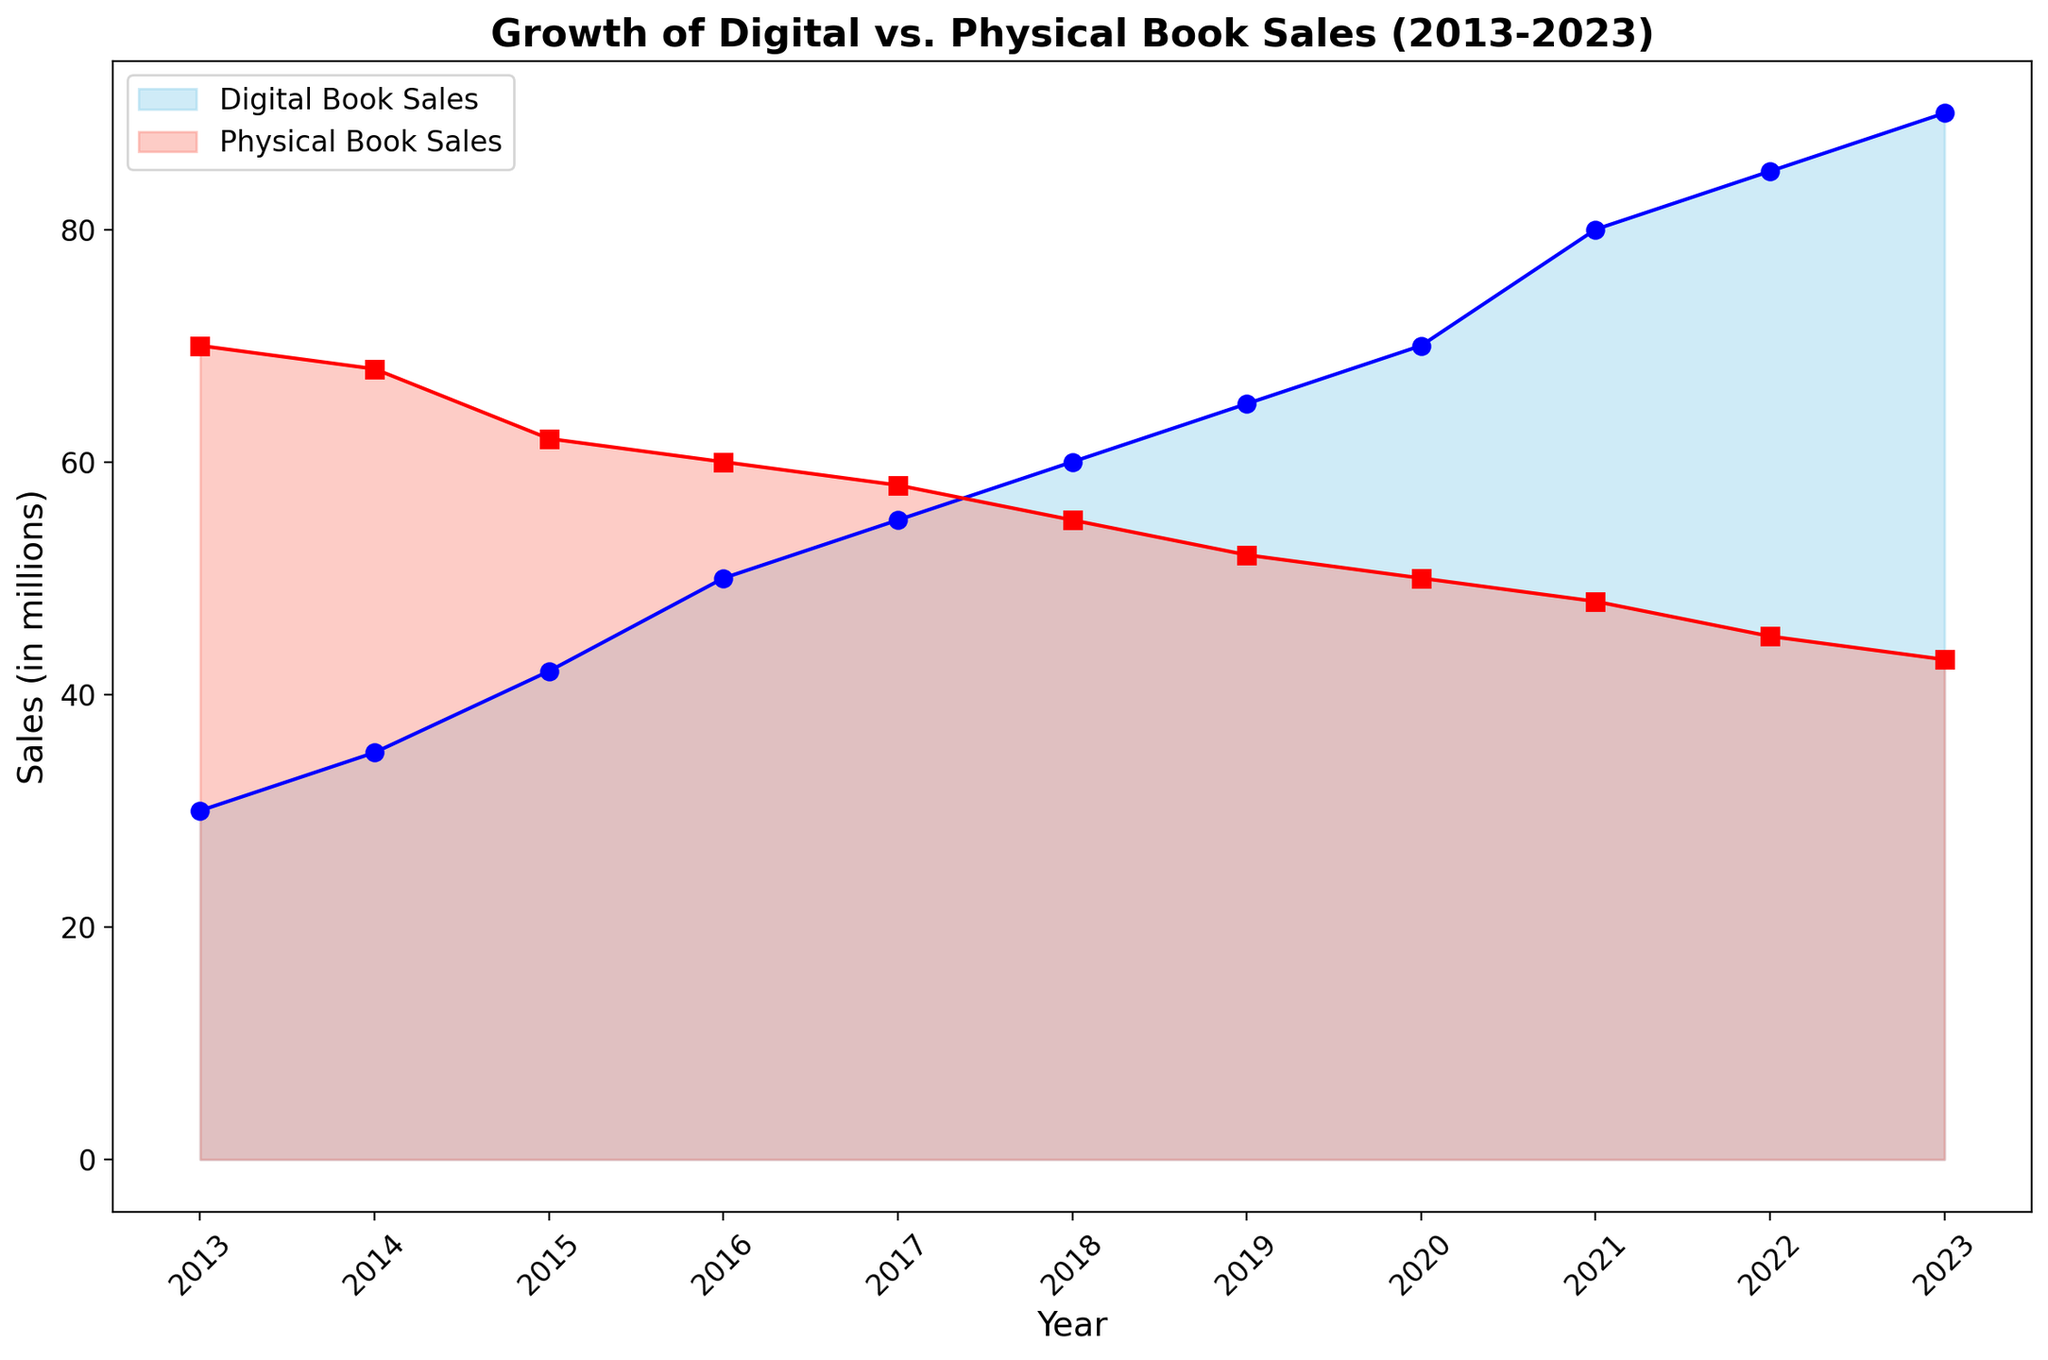What was the trend in digital book sales from 2013 to 2023? Digital book sales steadily increased from 30 million in 2013 to 90 million in 2023.
Answer: Increased How do physical book sales in 2023 compare to those in 2013? Physical book sales decreased from 70 million in 2013 to 43 million in 2023.
Answer: Decreased In which year did digital book sales exceed physical book sales for the first time? Digital book sales exceeded physical book sales for the first time in 2019 when they reached 65 million compared to physical books' 52 million.
Answer: 2019 What is the difference between digital book sales and physical book sales in 2023? Digital book sales in 2023 are 90 million and physical book sales are 43 million. The difference is 90 - 43 = 47 million.
Answer: 47 million Describe the visual colors used for digital and physical book sales in the area chart. The area representing digital book sales is colored in sky blue, while physical book sales are represented in salmon.
Answer: Digital: sky blue, Physical: salmon During which year did both digital and physical book sales have the smallest gap? In 2017, digital book sales were 55 million and physical book sales were 58 million, resulting in a gap of 3 million, which is the smallest.
Answer: 2017 What can you infer about the overall trend of physical book sales over the last decade? Physical book sales show a consistent declining trend from 70 million in 2013 to 43 million in 2023.
Answer: Declining How much did digital book sales increase between 2016 and 2023? Digital book sales increased from 50 million in 2016 to 90 million in 2023. The increase is 90 - 50 = 40 million.
Answer: 40 million Compare the rate of change between digital book sales and physical book sales from 2014 to 2018. Digital book sales increased from 35 million to 60 million, an increase of 25 million, whereas physical book sales decreased from 68 million to 55 million, a decrease of 13 million. Digital book sales increased at a higher rate.
Answer: Digital: +25 million; Physical: -13 million 